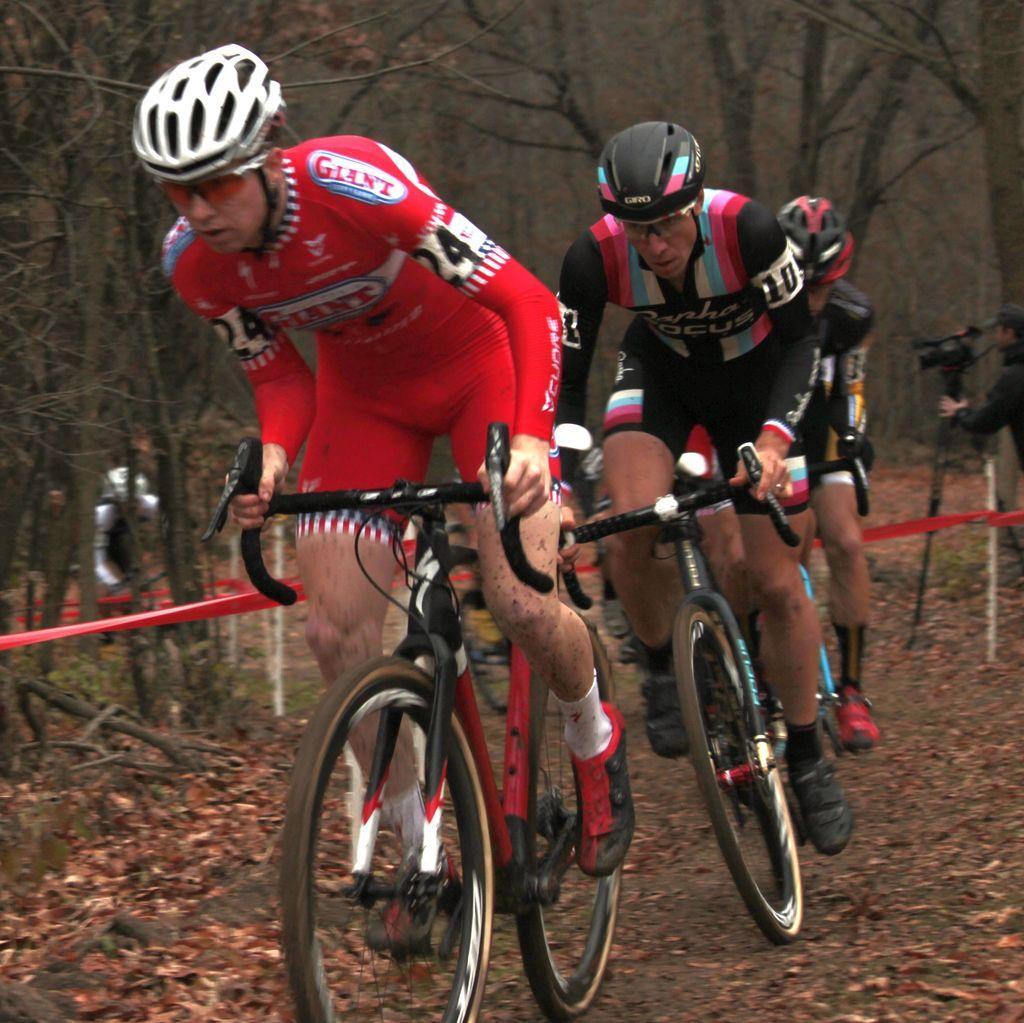In one or two sentences, can you explain what this image depicts? In this picture there are boys in the center of the image, they are cycling and there is a man on the right side of the image, he is taking video and there is another person and trees in the background area of the image. 